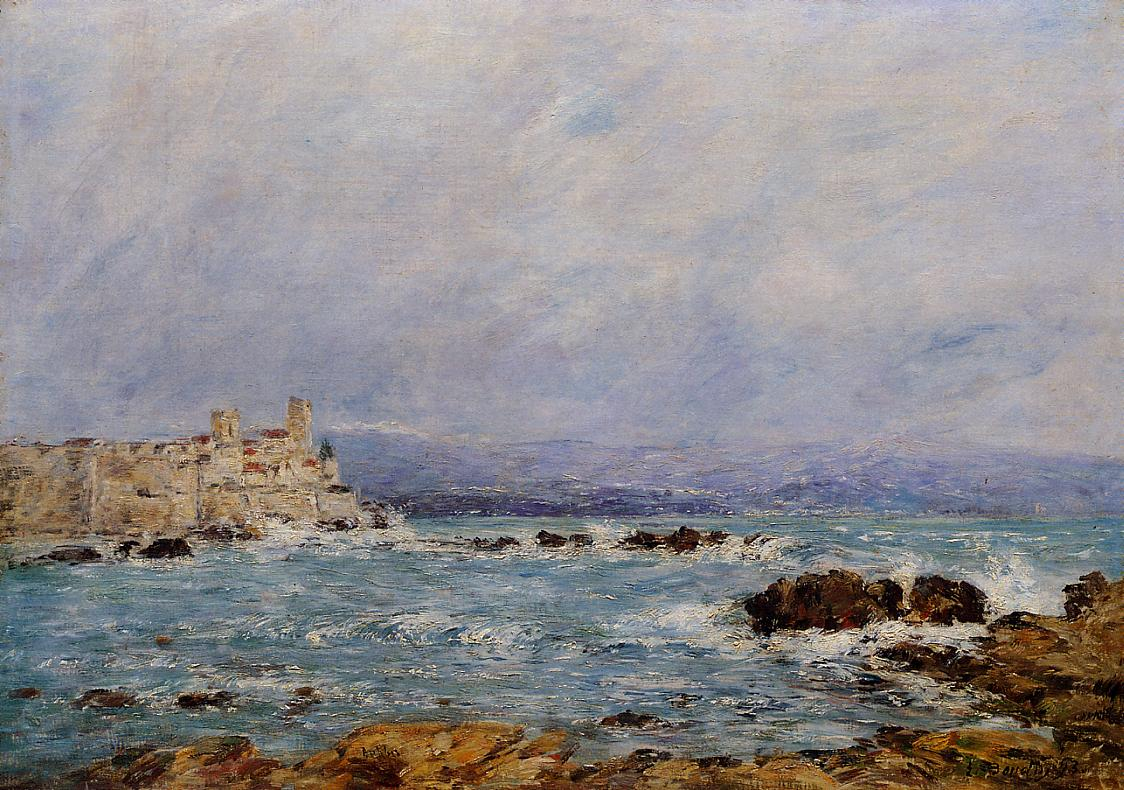How does the artist use color to convey mood in this painting? The artist, Claude Monet, masterfully utilizes a muted palette of blues, greens, and earth tones to evoke a serene yet somber mood. The soft blues of the sky and sea mixed with the turbulent whites of the waves create a sense of motion and emotion. The earthy tones of the rocky coast and fortress suggest stability and endurance amidst the changing tides. This careful color choice fosters a harmony between the elements, reflecting a calm resilience intrinsic to nature. 